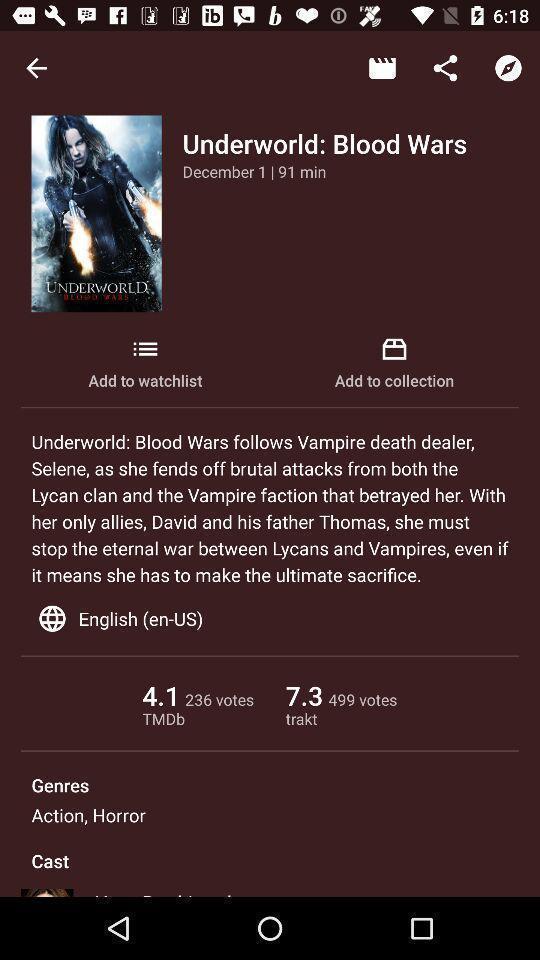Please provide a description for this image. Screen shows details of a movie. 